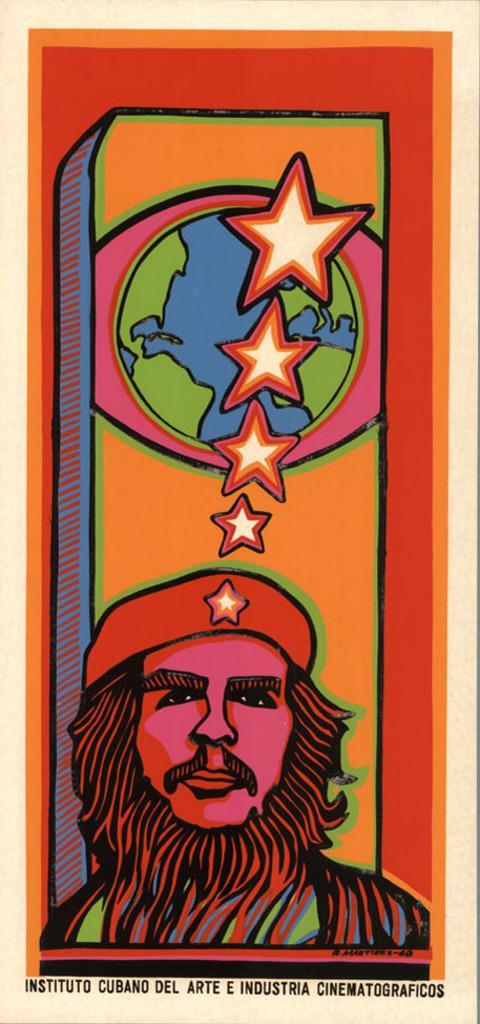Can you describe this image briefly? This is a poster, on this poster we can see a person, globe and star symbols, at the bottom we can see some text on it. 